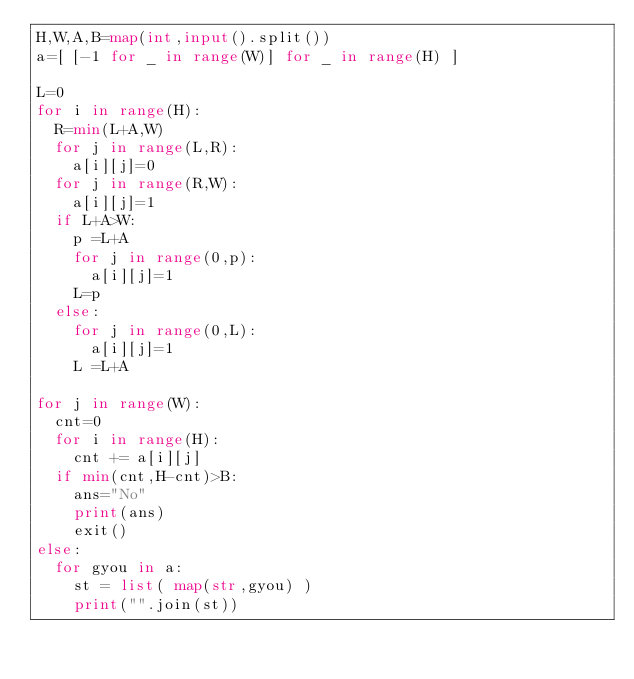Convert code to text. <code><loc_0><loc_0><loc_500><loc_500><_Python_>H,W,A,B=map(int,input().split())
a=[ [-1 for _ in range(W)] for _ in range(H) ]

L=0
for i in range(H):
  R=min(L+A,W)
  for j in range(L,R):
    a[i][j]=0
  for j in range(R,W):
    a[i][j]=1
  if L+A>W:
    p =L+A
    for j in range(0,p):
      a[i][j]=1
    L=p
  else:
    for j in range(0,L):
      a[i][j]=1
    L =L+A

for j in range(W):
  cnt=0
  for i in range(H):
    cnt += a[i][j]
  if min(cnt,H-cnt)>B:
    ans="No"
    print(ans)
    exit()
else:
  for gyou in a:
    st = list( map(str,gyou) )
    print("".join(st))</code> 